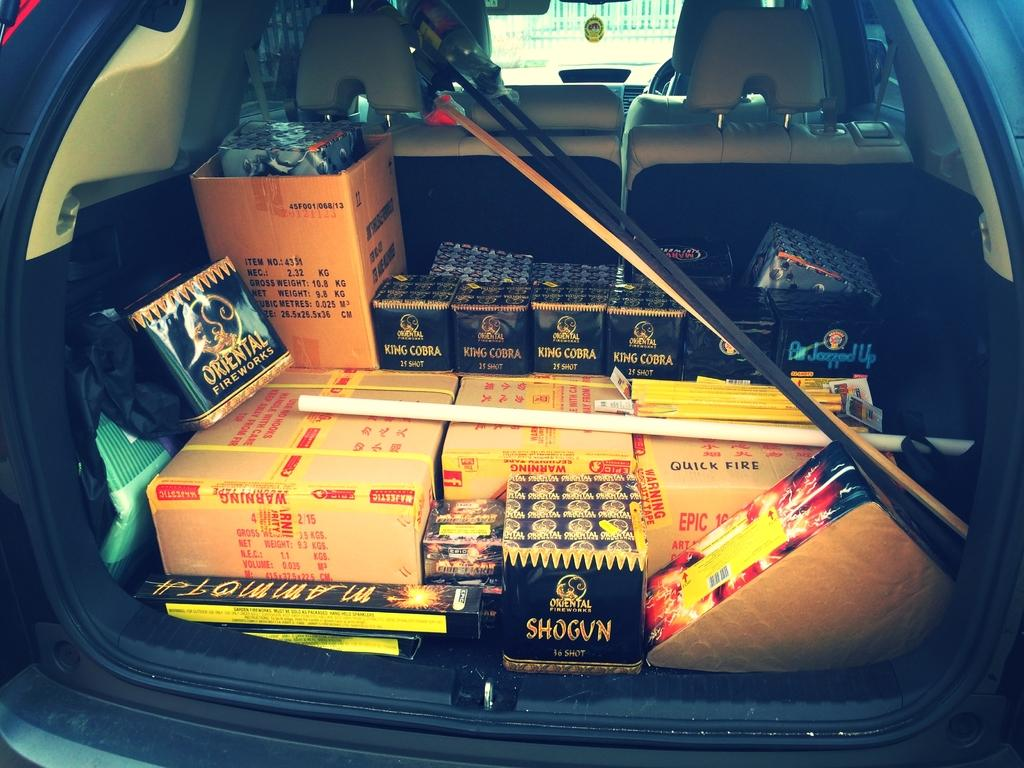What part of a car is visible in the image? The image shows the inner part of a car. What items can be seen inside the car? There are cardboard boxes inside the car. What type of account can be seen being pulled by the driver in the image? There is no account or driver present in the image; it only shows the inner part of a car with cardboard boxes inside. 